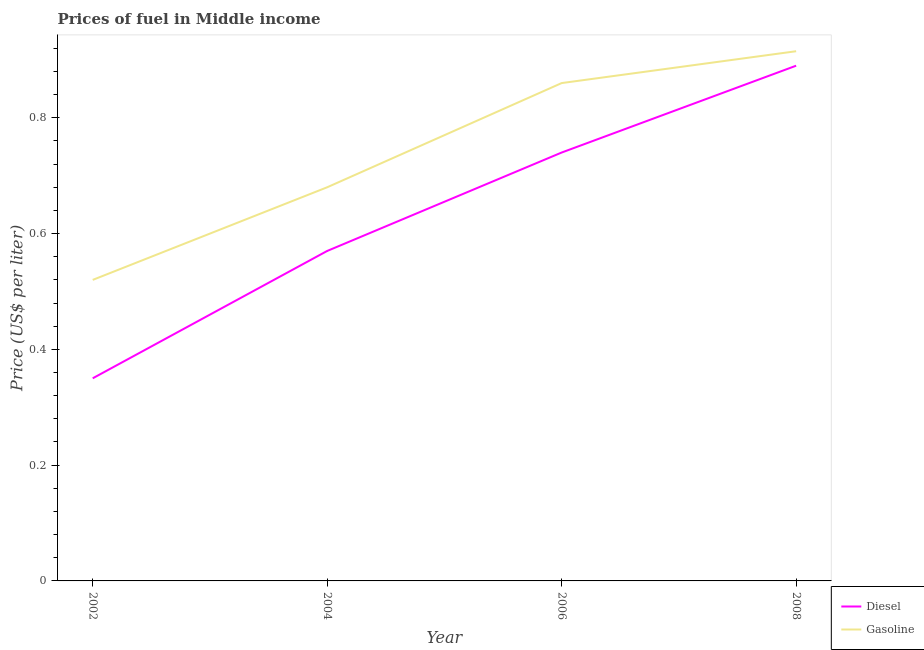How many different coloured lines are there?
Your answer should be very brief. 2. Does the line corresponding to diesel price intersect with the line corresponding to gasoline price?
Keep it short and to the point. No. Is the number of lines equal to the number of legend labels?
Provide a succinct answer. Yes. What is the diesel price in 2004?
Keep it short and to the point. 0.57. Across all years, what is the maximum gasoline price?
Keep it short and to the point. 0.92. Across all years, what is the minimum gasoline price?
Offer a terse response. 0.52. In which year was the gasoline price minimum?
Keep it short and to the point. 2002. What is the total diesel price in the graph?
Your response must be concise. 2.55. What is the difference between the gasoline price in 2004 and that in 2006?
Offer a terse response. -0.18. What is the difference between the diesel price in 2004 and the gasoline price in 2006?
Offer a terse response. -0.29. What is the average diesel price per year?
Provide a succinct answer. 0.64. In the year 2006, what is the difference between the gasoline price and diesel price?
Your response must be concise. 0.12. What is the ratio of the gasoline price in 2004 to that in 2006?
Your answer should be very brief. 0.79. Is the diesel price in 2004 less than that in 2008?
Your answer should be very brief. Yes. What is the difference between the highest and the second highest gasoline price?
Ensure brevity in your answer.  0.06. What is the difference between the highest and the lowest diesel price?
Provide a succinct answer. 0.54. Is the sum of the diesel price in 2004 and 2008 greater than the maximum gasoline price across all years?
Your response must be concise. Yes. Does the diesel price monotonically increase over the years?
Your response must be concise. Yes. How many lines are there?
Your answer should be compact. 2. How many years are there in the graph?
Your answer should be very brief. 4. What is the difference between two consecutive major ticks on the Y-axis?
Offer a terse response. 0.2. Does the graph contain any zero values?
Provide a short and direct response. No. Does the graph contain grids?
Make the answer very short. No. What is the title of the graph?
Your response must be concise. Prices of fuel in Middle income. What is the label or title of the Y-axis?
Provide a short and direct response. Price (US$ per liter). What is the Price (US$ per liter) of Diesel in 2002?
Keep it short and to the point. 0.35. What is the Price (US$ per liter) of Gasoline in 2002?
Provide a short and direct response. 0.52. What is the Price (US$ per liter) in Diesel in 2004?
Keep it short and to the point. 0.57. What is the Price (US$ per liter) of Gasoline in 2004?
Offer a terse response. 0.68. What is the Price (US$ per liter) in Diesel in 2006?
Your response must be concise. 0.74. What is the Price (US$ per liter) in Gasoline in 2006?
Your answer should be very brief. 0.86. What is the Price (US$ per liter) of Diesel in 2008?
Ensure brevity in your answer.  0.89. What is the Price (US$ per liter) in Gasoline in 2008?
Provide a short and direct response. 0.92. Across all years, what is the maximum Price (US$ per liter) in Diesel?
Provide a short and direct response. 0.89. Across all years, what is the maximum Price (US$ per liter) in Gasoline?
Ensure brevity in your answer.  0.92. Across all years, what is the minimum Price (US$ per liter) of Diesel?
Your response must be concise. 0.35. Across all years, what is the minimum Price (US$ per liter) in Gasoline?
Your response must be concise. 0.52. What is the total Price (US$ per liter) in Diesel in the graph?
Ensure brevity in your answer.  2.55. What is the total Price (US$ per liter) of Gasoline in the graph?
Offer a very short reply. 2.98. What is the difference between the Price (US$ per liter) in Diesel in 2002 and that in 2004?
Provide a succinct answer. -0.22. What is the difference between the Price (US$ per liter) in Gasoline in 2002 and that in 2004?
Make the answer very short. -0.16. What is the difference between the Price (US$ per liter) in Diesel in 2002 and that in 2006?
Provide a succinct answer. -0.39. What is the difference between the Price (US$ per liter) in Gasoline in 2002 and that in 2006?
Offer a very short reply. -0.34. What is the difference between the Price (US$ per liter) of Diesel in 2002 and that in 2008?
Your answer should be compact. -0.54. What is the difference between the Price (US$ per liter) in Gasoline in 2002 and that in 2008?
Ensure brevity in your answer.  -0.4. What is the difference between the Price (US$ per liter) in Diesel in 2004 and that in 2006?
Provide a succinct answer. -0.17. What is the difference between the Price (US$ per liter) in Gasoline in 2004 and that in 2006?
Provide a succinct answer. -0.18. What is the difference between the Price (US$ per liter) of Diesel in 2004 and that in 2008?
Your answer should be compact. -0.32. What is the difference between the Price (US$ per liter) in Gasoline in 2004 and that in 2008?
Give a very brief answer. -0.23. What is the difference between the Price (US$ per liter) of Gasoline in 2006 and that in 2008?
Your response must be concise. -0.06. What is the difference between the Price (US$ per liter) of Diesel in 2002 and the Price (US$ per liter) of Gasoline in 2004?
Give a very brief answer. -0.33. What is the difference between the Price (US$ per liter) of Diesel in 2002 and the Price (US$ per liter) of Gasoline in 2006?
Offer a terse response. -0.51. What is the difference between the Price (US$ per liter) of Diesel in 2002 and the Price (US$ per liter) of Gasoline in 2008?
Offer a terse response. -0.56. What is the difference between the Price (US$ per liter) of Diesel in 2004 and the Price (US$ per liter) of Gasoline in 2006?
Give a very brief answer. -0.29. What is the difference between the Price (US$ per liter) in Diesel in 2004 and the Price (US$ per liter) in Gasoline in 2008?
Your answer should be very brief. -0.34. What is the difference between the Price (US$ per liter) of Diesel in 2006 and the Price (US$ per liter) of Gasoline in 2008?
Give a very brief answer. -0.17. What is the average Price (US$ per liter) in Diesel per year?
Provide a succinct answer. 0.64. What is the average Price (US$ per liter) of Gasoline per year?
Provide a succinct answer. 0.74. In the year 2002, what is the difference between the Price (US$ per liter) of Diesel and Price (US$ per liter) of Gasoline?
Provide a succinct answer. -0.17. In the year 2004, what is the difference between the Price (US$ per liter) in Diesel and Price (US$ per liter) in Gasoline?
Ensure brevity in your answer.  -0.11. In the year 2006, what is the difference between the Price (US$ per liter) in Diesel and Price (US$ per liter) in Gasoline?
Your response must be concise. -0.12. In the year 2008, what is the difference between the Price (US$ per liter) in Diesel and Price (US$ per liter) in Gasoline?
Provide a succinct answer. -0.03. What is the ratio of the Price (US$ per liter) in Diesel in 2002 to that in 2004?
Keep it short and to the point. 0.61. What is the ratio of the Price (US$ per liter) of Gasoline in 2002 to that in 2004?
Your answer should be compact. 0.76. What is the ratio of the Price (US$ per liter) of Diesel in 2002 to that in 2006?
Your answer should be very brief. 0.47. What is the ratio of the Price (US$ per liter) of Gasoline in 2002 to that in 2006?
Keep it short and to the point. 0.6. What is the ratio of the Price (US$ per liter) in Diesel in 2002 to that in 2008?
Make the answer very short. 0.39. What is the ratio of the Price (US$ per liter) of Gasoline in 2002 to that in 2008?
Provide a short and direct response. 0.57. What is the ratio of the Price (US$ per liter) of Diesel in 2004 to that in 2006?
Your answer should be very brief. 0.77. What is the ratio of the Price (US$ per liter) of Gasoline in 2004 to that in 2006?
Ensure brevity in your answer.  0.79. What is the ratio of the Price (US$ per liter) of Diesel in 2004 to that in 2008?
Make the answer very short. 0.64. What is the ratio of the Price (US$ per liter) in Gasoline in 2004 to that in 2008?
Keep it short and to the point. 0.74. What is the ratio of the Price (US$ per liter) in Diesel in 2006 to that in 2008?
Your response must be concise. 0.83. What is the ratio of the Price (US$ per liter) in Gasoline in 2006 to that in 2008?
Make the answer very short. 0.94. What is the difference between the highest and the second highest Price (US$ per liter) of Gasoline?
Your response must be concise. 0.06. What is the difference between the highest and the lowest Price (US$ per liter) of Diesel?
Your response must be concise. 0.54. What is the difference between the highest and the lowest Price (US$ per liter) of Gasoline?
Give a very brief answer. 0.4. 